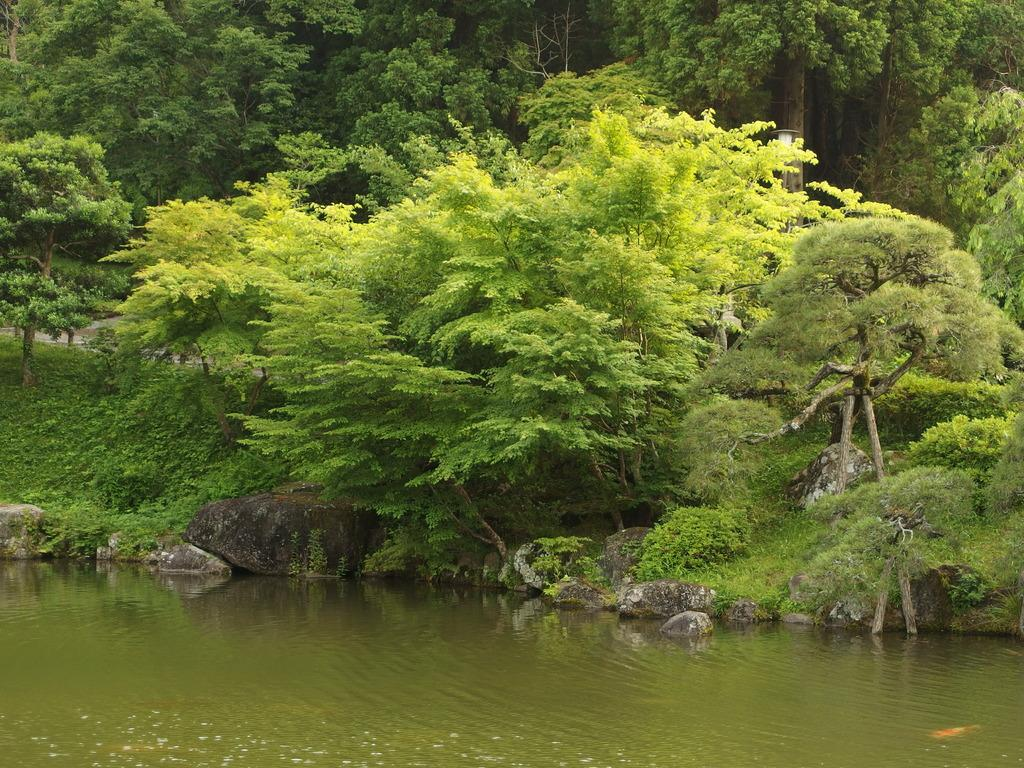What type of vegetation can be seen in the image? There are trees and plants in the image. What other objects can be seen in the image? There are stones and branches visible in the image. What natural element is present in the image? Water is visible in the image. How many girls are sitting on the oven in the image? There are no girls or ovens present in the image. What emotion is being expressed by the plants in the image? Plants do not express emotions, so it is not possible to determine what emotion they might be expressing. 